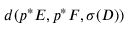Convert formula to latex. <formula><loc_0><loc_0><loc_500><loc_500>d ( p ^ { * } E , p ^ { * } F , \sigma ( D ) )</formula> 